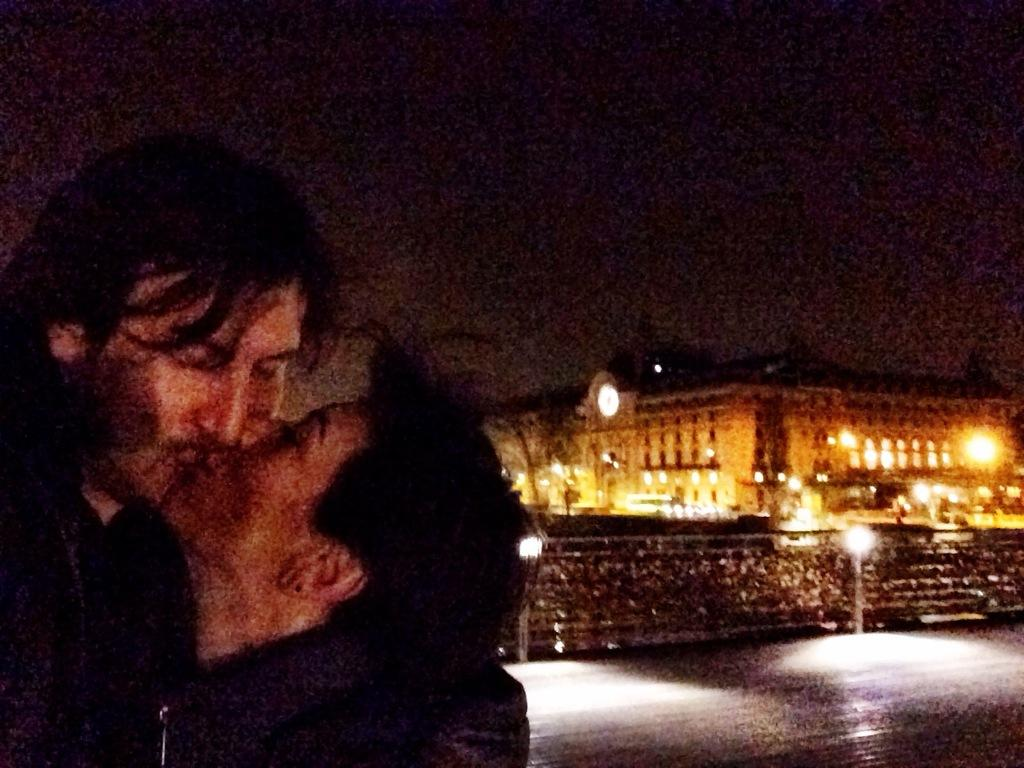What are the two persons in the image doing? The two persons are kissing in the image. What type of structure can be seen in the image? There is a building in the image. What are the poles used for in the image? The poles are not explicitly described in the facts, so we cannot determine their purpose. What architectural features are present in the building? There are windows in the image. What type of illumination is present in the image? There are lights in the image. What can be seen in the background of the image? The sky is visible in the background of the image. Can you see any kittens playing near the lake in the image? There is no lake or kittens present in the image. What type of appliance is being used by the persons in the image? The facts do not mention any appliances being used by the persons in the image. 